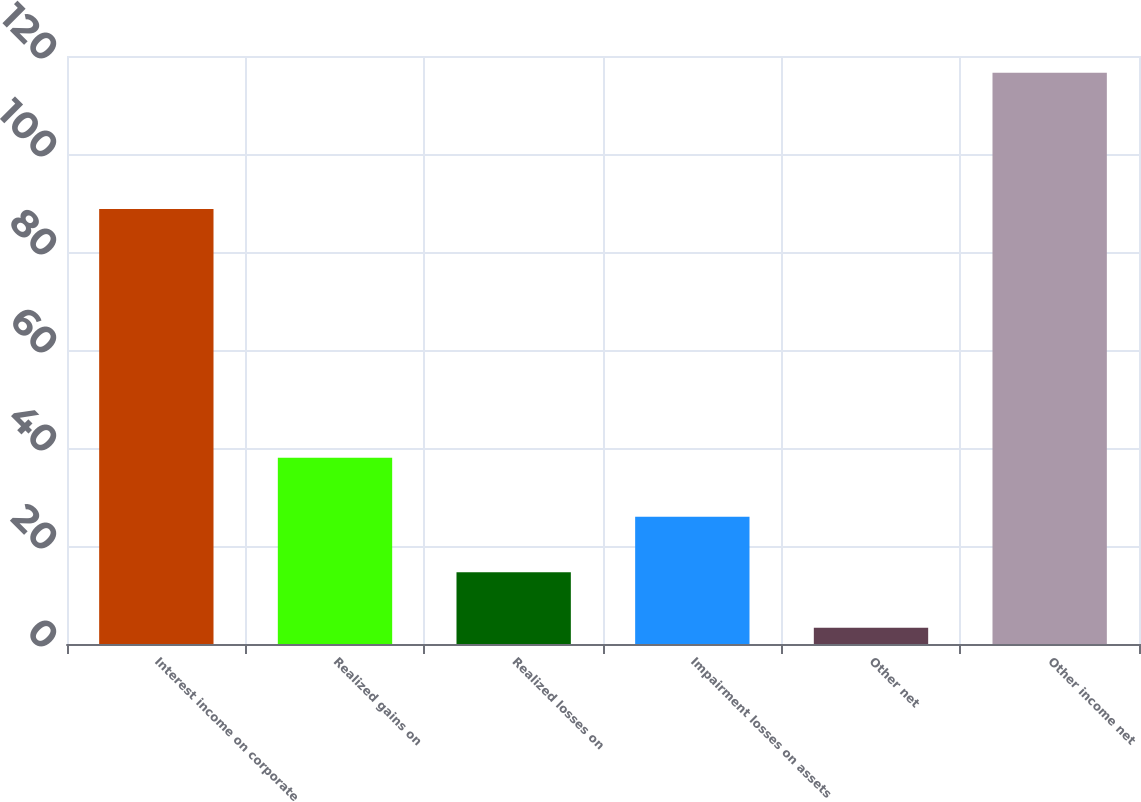Convert chart to OTSL. <chart><loc_0><loc_0><loc_500><loc_500><bar_chart><fcel>Interest income on corporate<fcel>Realized gains on<fcel>Realized losses on<fcel>Impairment losses on assets<fcel>Other net<fcel>Other income net<nl><fcel>88.8<fcel>38<fcel>14.63<fcel>25.96<fcel>3.3<fcel>116.6<nl></chart> 